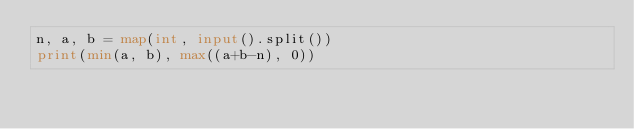Convert code to text. <code><loc_0><loc_0><loc_500><loc_500><_Python_>n, a, b = map(int, input().split())
print(min(a, b), max((a+b-n), 0))</code> 